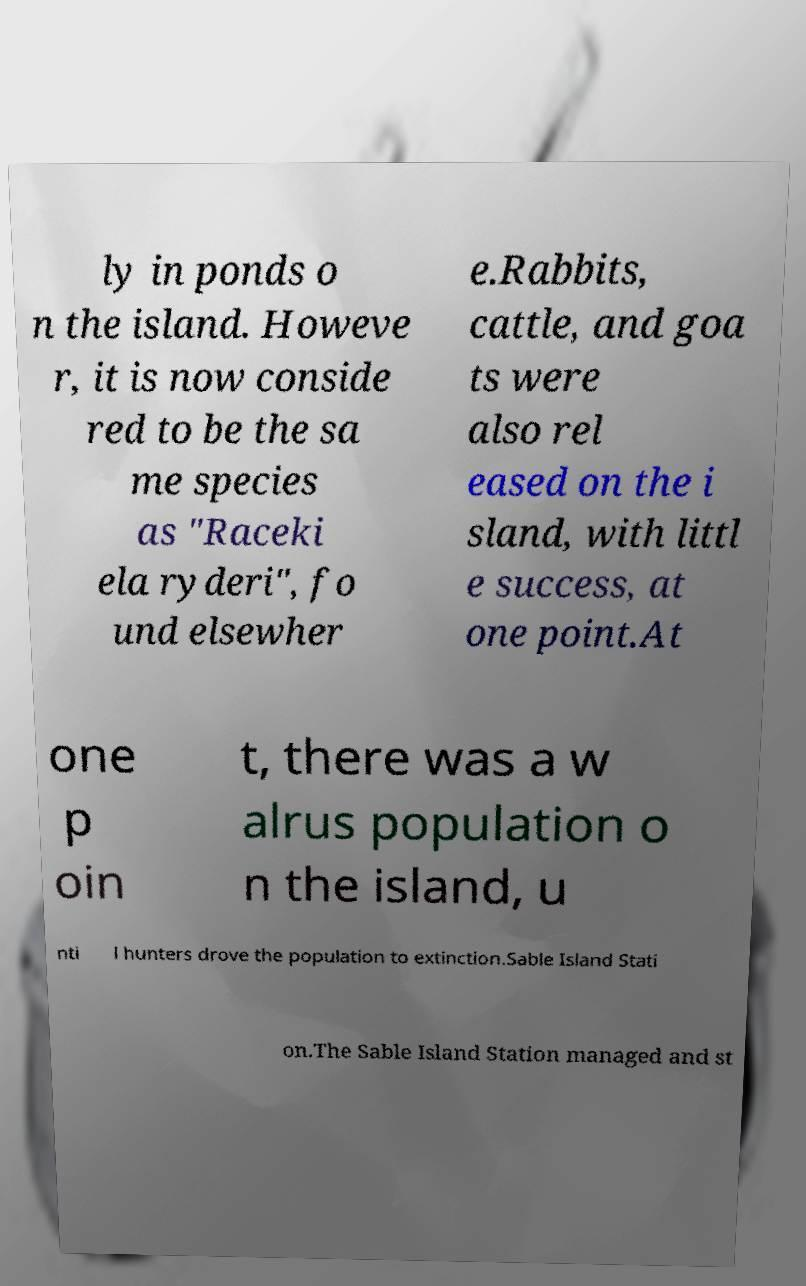Could you extract and type out the text from this image? ly in ponds o n the island. Howeve r, it is now conside red to be the sa me species as "Raceki ela ryderi", fo und elsewher e.Rabbits, cattle, and goa ts were also rel eased on the i sland, with littl e success, at one point.At one p oin t, there was a w alrus population o n the island, u nti l hunters drove the population to extinction.Sable Island Stati on.The Sable Island Station managed and st 